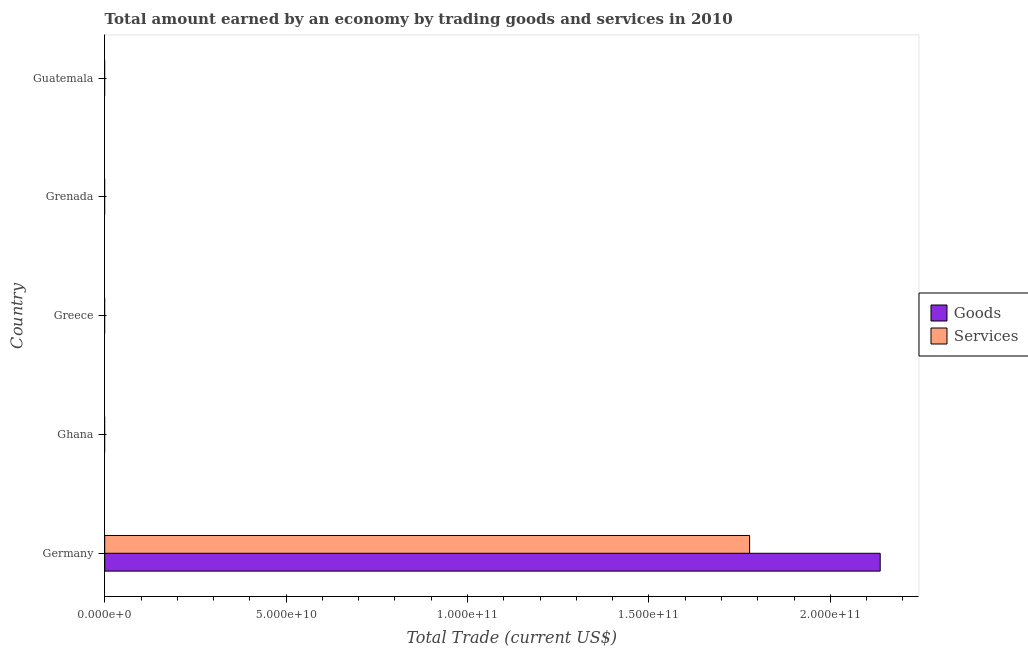How many different coloured bars are there?
Keep it short and to the point. 2. How many bars are there on the 5th tick from the top?
Your answer should be very brief. 2. How many bars are there on the 5th tick from the bottom?
Keep it short and to the point. 0. In how many cases, is the number of bars for a given country not equal to the number of legend labels?
Make the answer very short. 4. What is the amount earned by trading services in Guatemala?
Make the answer very short. 0. Across all countries, what is the maximum amount earned by trading goods?
Your answer should be compact. 2.14e+11. Across all countries, what is the minimum amount earned by trading services?
Ensure brevity in your answer.  0. What is the total amount earned by trading goods in the graph?
Offer a very short reply. 2.14e+11. What is the difference between the amount earned by trading services in Guatemala and the amount earned by trading goods in Germany?
Keep it short and to the point. -2.14e+11. What is the average amount earned by trading services per country?
Provide a succinct answer. 3.56e+1. What is the difference between the amount earned by trading services and amount earned by trading goods in Germany?
Provide a succinct answer. -3.60e+1. What is the difference between the highest and the lowest amount earned by trading services?
Offer a terse response. 1.78e+11. In how many countries, is the amount earned by trading goods greater than the average amount earned by trading goods taken over all countries?
Your answer should be very brief. 1. Are the values on the major ticks of X-axis written in scientific E-notation?
Keep it short and to the point. Yes. Does the graph contain grids?
Offer a very short reply. No. Where does the legend appear in the graph?
Offer a very short reply. Center right. How are the legend labels stacked?
Keep it short and to the point. Vertical. What is the title of the graph?
Offer a very short reply. Total amount earned by an economy by trading goods and services in 2010. Does "From production" appear as one of the legend labels in the graph?
Give a very brief answer. No. What is the label or title of the X-axis?
Give a very brief answer. Total Trade (current US$). What is the Total Trade (current US$) in Goods in Germany?
Offer a very short reply. 2.14e+11. What is the Total Trade (current US$) in Services in Germany?
Provide a succinct answer. 1.78e+11. What is the Total Trade (current US$) of Goods in Ghana?
Offer a very short reply. 0. What is the Total Trade (current US$) of Services in Greece?
Keep it short and to the point. 0. Across all countries, what is the maximum Total Trade (current US$) in Goods?
Give a very brief answer. 2.14e+11. Across all countries, what is the maximum Total Trade (current US$) of Services?
Provide a short and direct response. 1.78e+11. Across all countries, what is the minimum Total Trade (current US$) of Goods?
Offer a terse response. 0. Across all countries, what is the minimum Total Trade (current US$) of Services?
Make the answer very short. 0. What is the total Total Trade (current US$) of Goods in the graph?
Keep it short and to the point. 2.14e+11. What is the total Total Trade (current US$) in Services in the graph?
Offer a terse response. 1.78e+11. What is the average Total Trade (current US$) in Goods per country?
Offer a very short reply. 4.27e+1. What is the average Total Trade (current US$) in Services per country?
Give a very brief answer. 3.56e+1. What is the difference between the Total Trade (current US$) in Goods and Total Trade (current US$) in Services in Germany?
Ensure brevity in your answer.  3.60e+1. What is the difference between the highest and the lowest Total Trade (current US$) in Goods?
Ensure brevity in your answer.  2.14e+11. What is the difference between the highest and the lowest Total Trade (current US$) in Services?
Your response must be concise. 1.78e+11. 